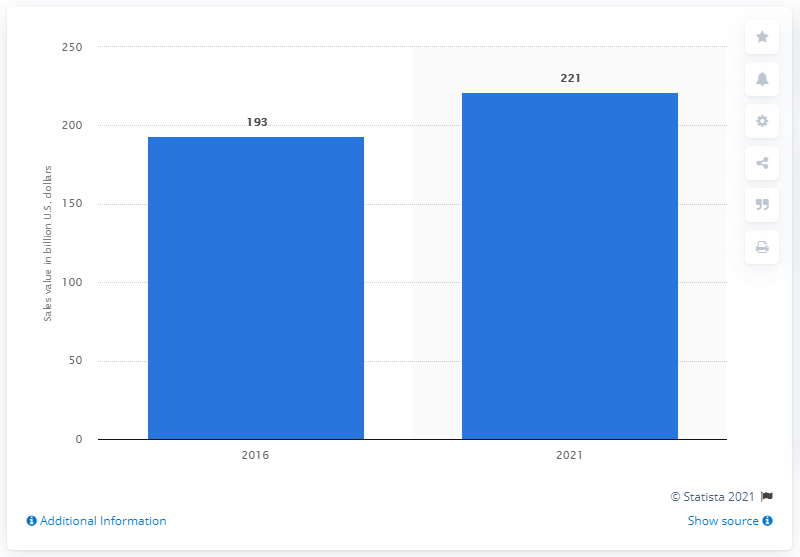Identify some key points in this picture. The forecast for the Latin American food and beverage industry in 2021 is... According to data released in 2016, the Latin American food and beverage sector generated a total revenue of 193. By 2021, the projected sales of the Latin American food and beverage sector are expected to reach XXXX. 